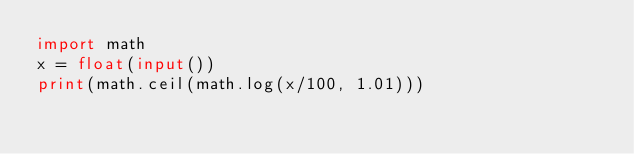Convert code to text. <code><loc_0><loc_0><loc_500><loc_500><_Python_>import math
x = float(input())
print(math.ceil(math.log(x/100, 1.01)))</code> 